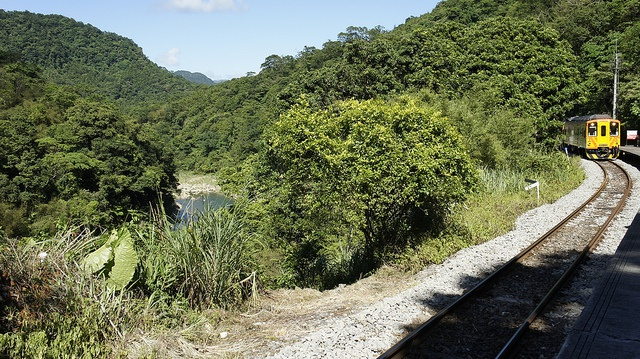Describe the objects in this image and their specific colors. I can see a train in lightblue, black, yellow, darkgreen, and gray tones in this image. 